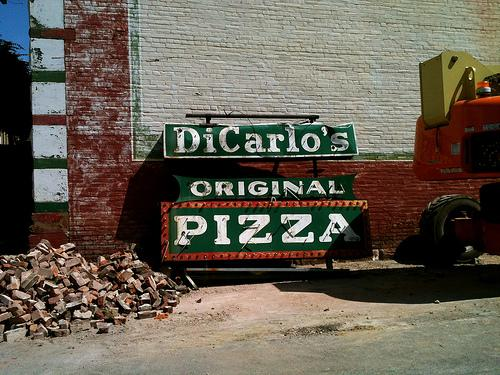Narrate what you see in the image using simple sentence structure. There is a green sign. It says "Dicarlos Original Pizza". It is by a brick building. There are old bricks on the ground. A truck is nearby. Provide a concise description of the main elements in the image. A green "Dicarlos Original Pizza" sign leans on a brick building with a pile of old bricks, a tire, and a truck close by. Mention the primary focus of the image and provide a brief description. The primary focus is a green sign with white letters, reading "Dicarlos Original Pizza", leaning against a brick building near a pile of old bricks and a large truck. Describe the essential components in the image and their relationship with each other. A green and white pizza sign leans against a multi-colored brick building; it is positioned near an old pile of bricks and a large truck, suggesting a relation to the establishment or construction nearby. Give a detailed overview of the image, including the main elements and their arrangement. A green and red sign for "Dicarlos Original Pizza" is the main element, leaning against a brick building with different colored bricks, nearby there's a pile of old bricks, a large truck, and a tire from construction equipment. Explain the key visual components of the image in few words. Green pizza sign, brick building, old bricks, large truck. Elaborate on the primary object in the image and its surrounding elements. The central object is a green sign with white text for "Dicarlos Original Pizza", surrounded by a brick building, a pile of broken bricks, and a large truck parked nearby. Using descriptive language, paint a picture of the scene in the image. A bright green sign emblazoned with the inviting words "Dicarlos Original Pizza" leans comfortably against the warm, textural brick building, graced by the presence of time-worn bricks and a seasoned large truck. Relate the primary objects and their context in the image. The green "Dicarlos Original Pizza" sign leaning against a brick building conveys a sense of nostalgia and ties it to the pile of old bricks and the large truck in the vicinity, hinting at a story of construction or renovation. Describe the scene depicted in the image in one sentence. A green and white pizza sign leans against a brick building by a pile of old bricks, a large truck, and other objects. 